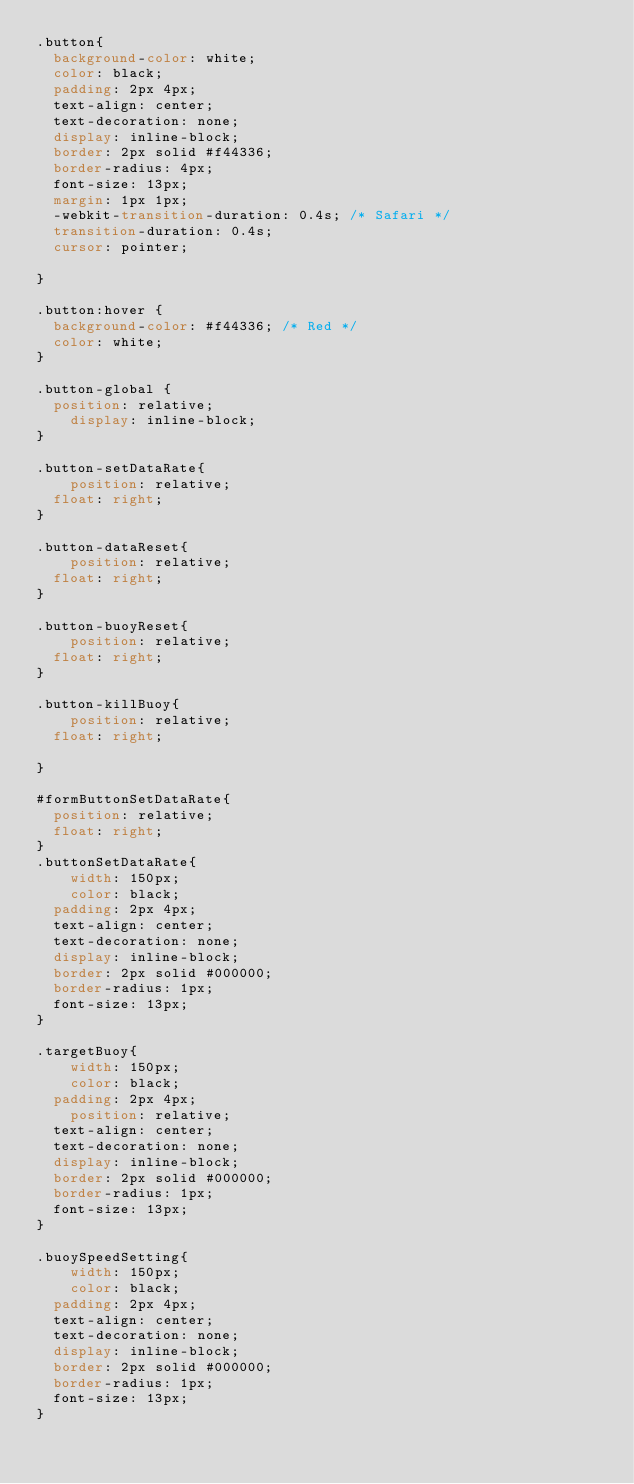Convert code to text. <code><loc_0><loc_0><loc_500><loc_500><_CSS_>.button{
	background-color: white;
	color: black;
	padding: 2px 4px;
	text-align: center;
	text-decoration: none;
	display: inline-block;
	border: 2px solid #f44336;
	border-radius: 4px;
	font-size: 13px;
	margin: 1px 1px;
	-webkit-transition-duration: 0.4s; /* Safari */
	transition-duration: 0.4s;
	cursor: pointer;

}

.button:hover {
	background-color: #f44336; /* Red */
	color: white;
}

.button-global {
	position: relative;
    display: inline-block;
}

.button-setDataRate{
    position: relative;
	float: right;
}

.button-dataReset{
    position: relative;
	float: right;
}

.button-buoyReset{
    position: relative;
	float: right;
}

.button-killBuoy{
    position: relative;
	float: right;

}

#formButtonSetDataRate{
	position: relative;
	float: right;
}
.buttonSetDataRate{
    width: 150px;
    color: black;
	padding: 2px 4px;
	text-align: center;
	text-decoration: none;
	display: inline-block;
	border: 2px solid #000000;
	border-radius: 1px;
	font-size: 13px;
}

.targetBuoy{
    width: 150px;
    color: black;
	padding: 2px 4px;
    position: relative;
	text-align: center;
	text-decoration: none;
	display: inline-block;
	border: 2px solid #000000;
	border-radius: 1px;
	font-size: 13px;
}

.buoySpeedSetting{
    width: 150px;
    color: black;
	padding: 2px 4px;
	text-align: center;
	text-decoration: none;
	display: inline-block;
	border: 2px solid #000000;
	border-radius: 1px;
	font-size: 13px;
}

</code> 